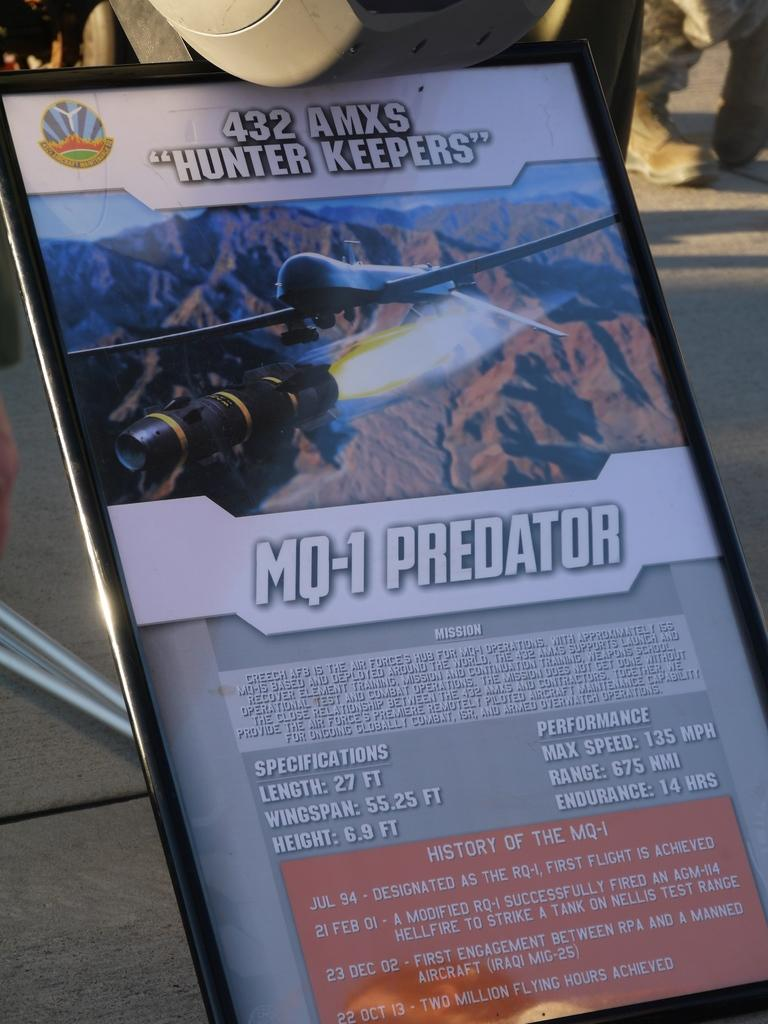Provide a one-sentence caption for the provided image. A display ad for the MQ-1 Predator that includes its specifications. 